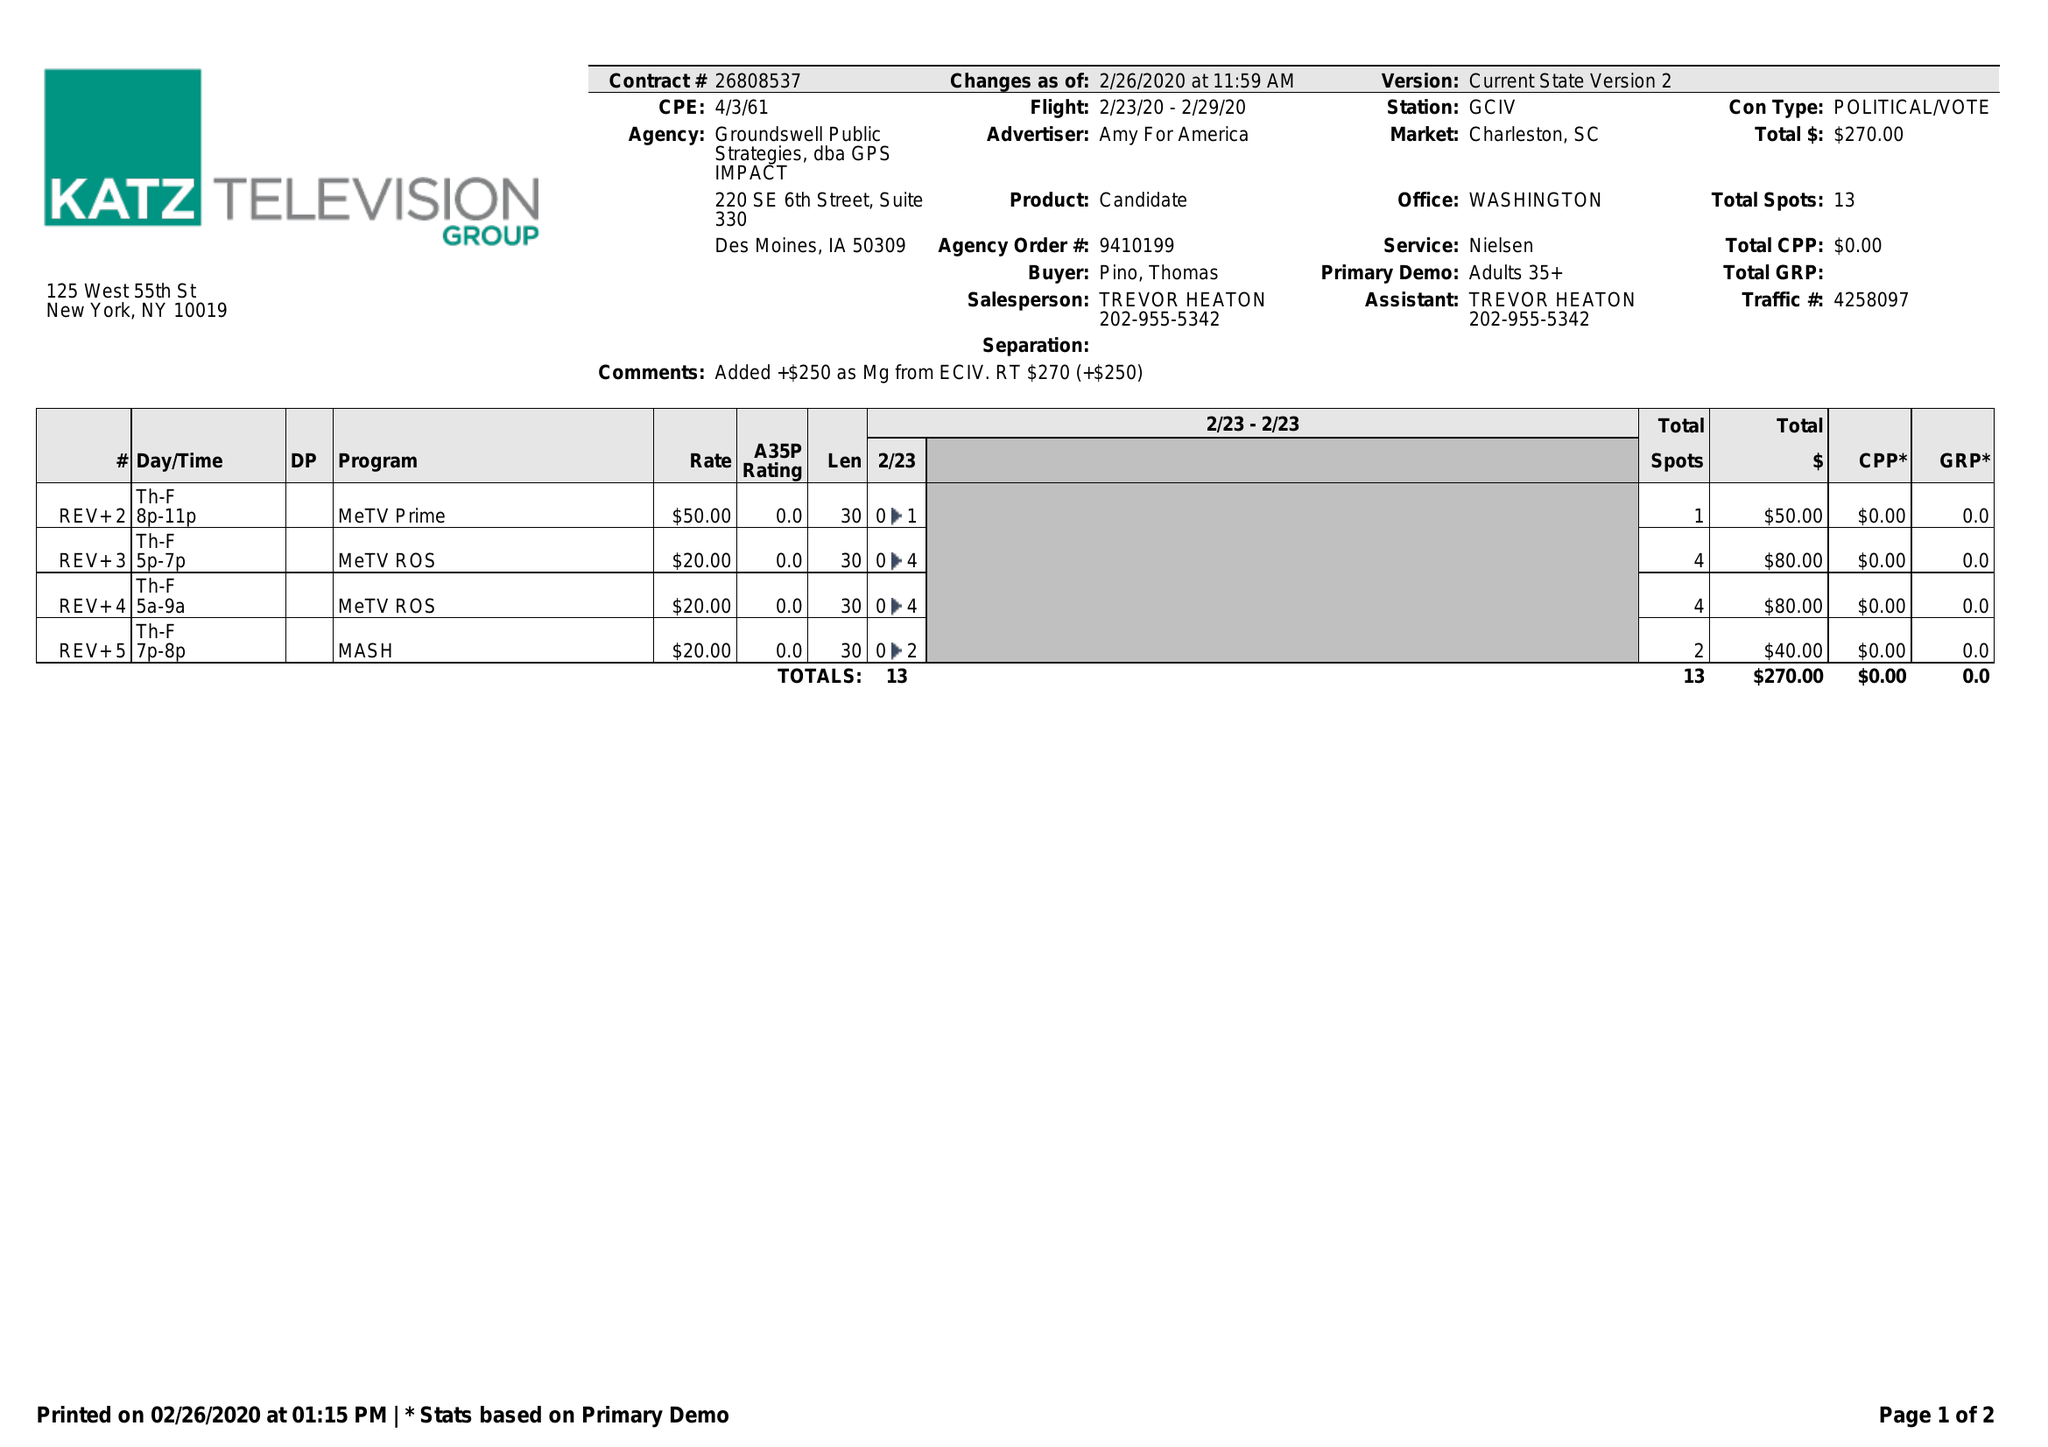What is the value for the gross_amount?
Answer the question using a single word or phrase. 270.00 